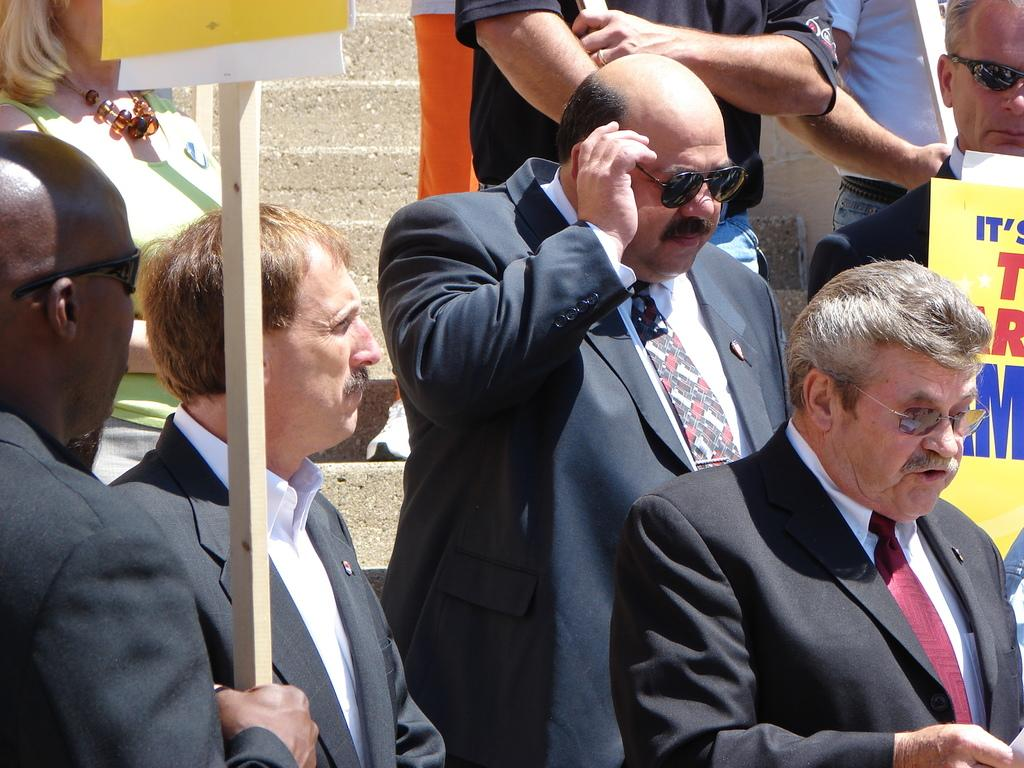How many people are in the image? There are people in the image, but the exact number is not specified. What is the person on the right side of the image holding? The person on the right side of the image is holding a stick with a board. What can be seen in the background of the image? There are steps visible in the background of the image. What type of wine is being served to the giants in the image? There are no giants or wine present in the image. 